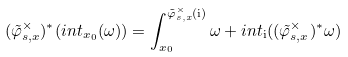<formula> <loc_0><loc_0><loc_500><loc_500>( \tilde { \varphi } _ { s , x } ^ { \times } ) ^ { * } ( i n t _ { x _ { 0 } } ( \omega ) ) = \int _ { x _ { 0 } } ^ { \tilde { \varphi } _ { s , x } ^ { \times } ( \mathrm i ) } \omega + i n t _ { \mathrm i } ( ( \tilde { \varphi } _ { s , x } ^ { \times } ) ^ { * } \omega )</formula> 